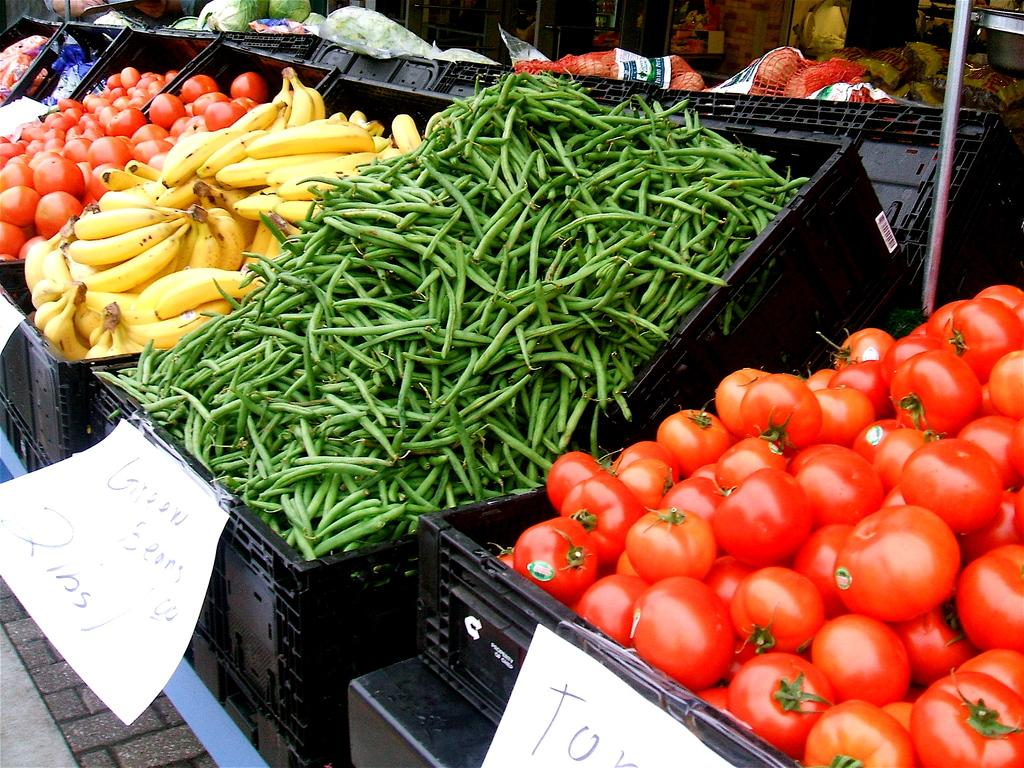What type of location is shown in the image? The image depicts a market. What specific fruits and vegetables can be seen in the baskets? There are tomatoes, beans, bananas, and other fruits and vegetables in the baskets. How are the prices of the fruits and vegetables displayed? Price boards are hanging from the baskets. What type of roof can be seen on the banana in the image? There is no roof on the banana in the image, as bananas do not have roofs. 